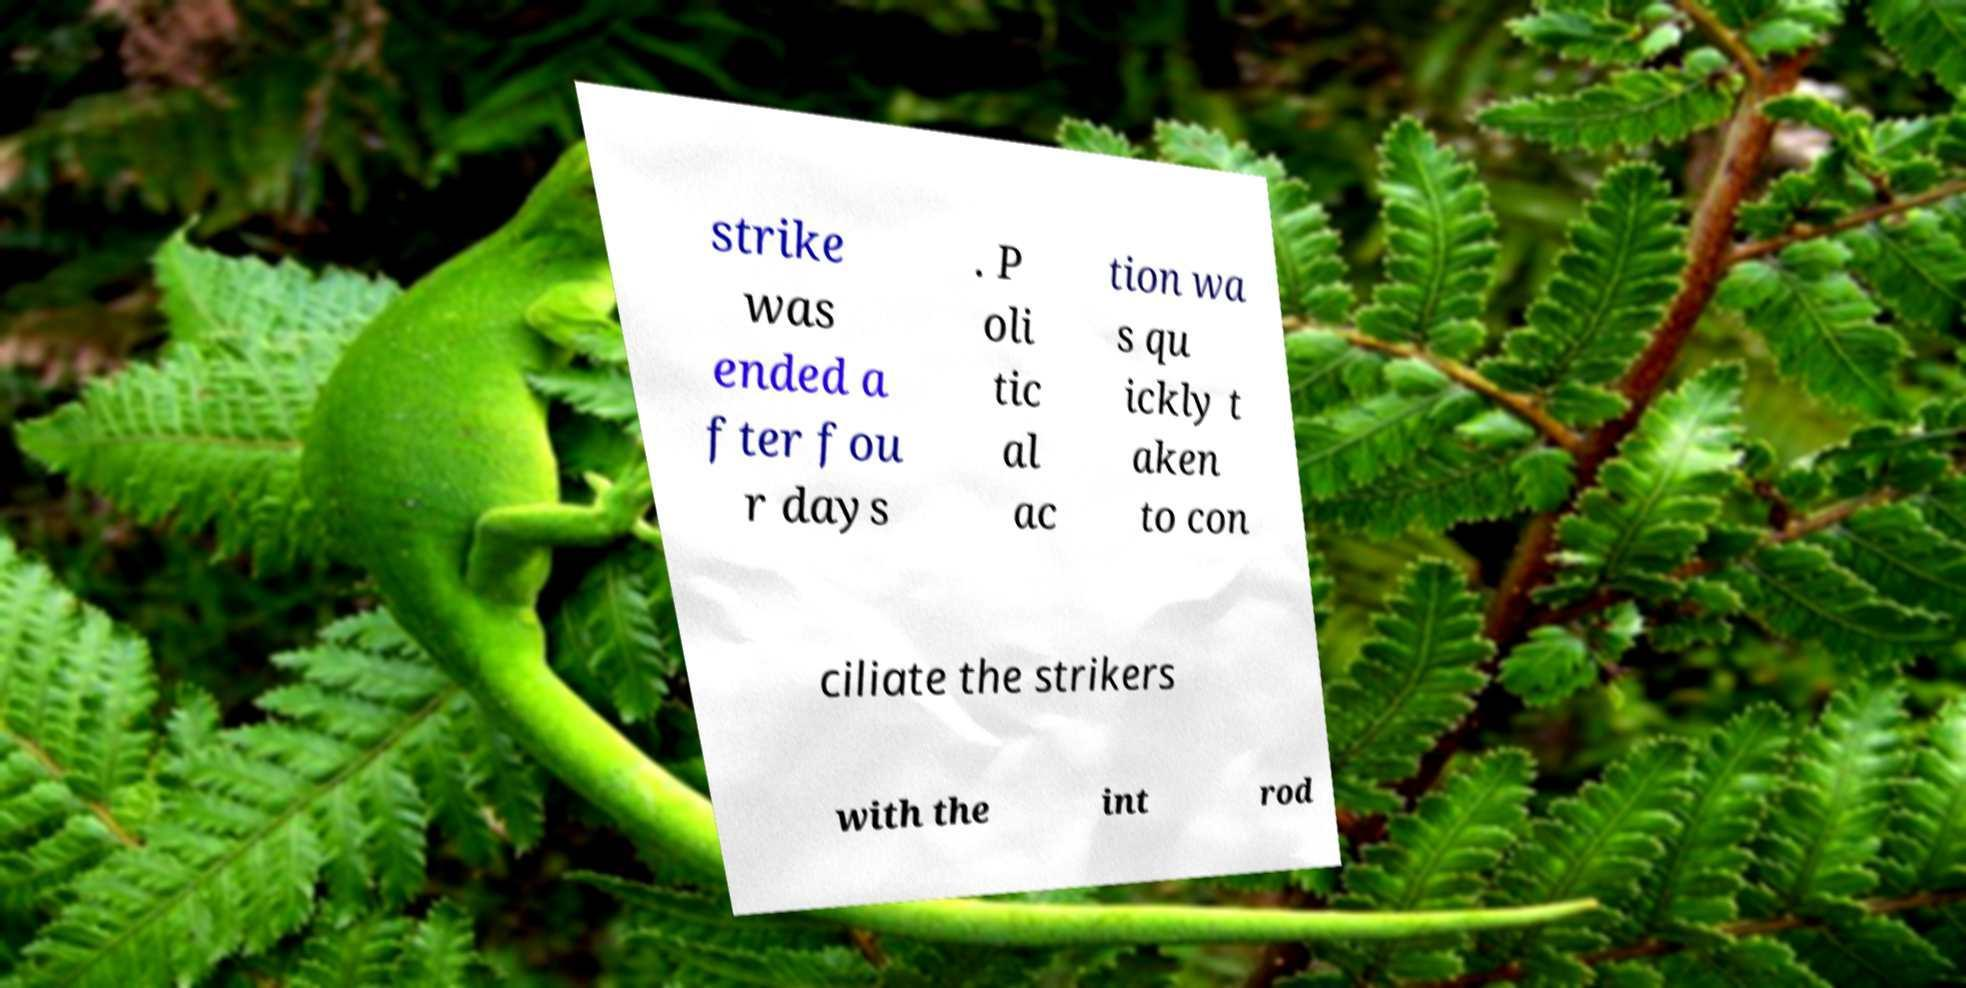Can you accurately transcribe the text from the provided image for me? strike was ended a fter fou r days . P oli tic al ac tion wa s qu ickly t aken to con ciliate the strikers with the int rod 